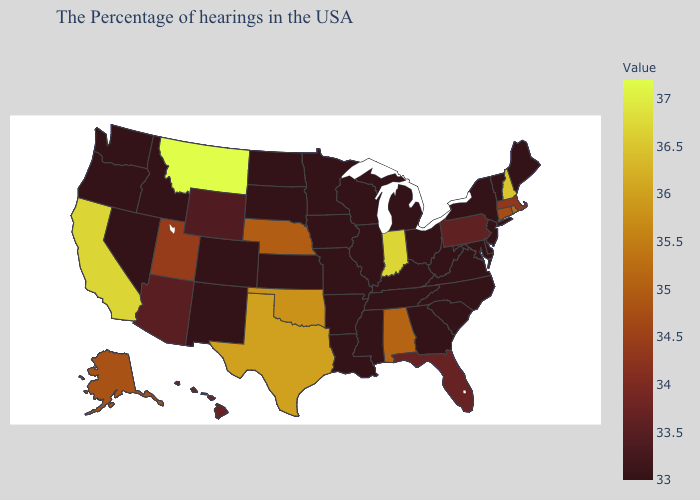Does Kansas have the lowest value in the MidWest?
Quick response, please. Yes. Does the map have missing data?
Be succinct. No. Does Maine have the lowest value in the USA?
Concise answer only. Yes. 